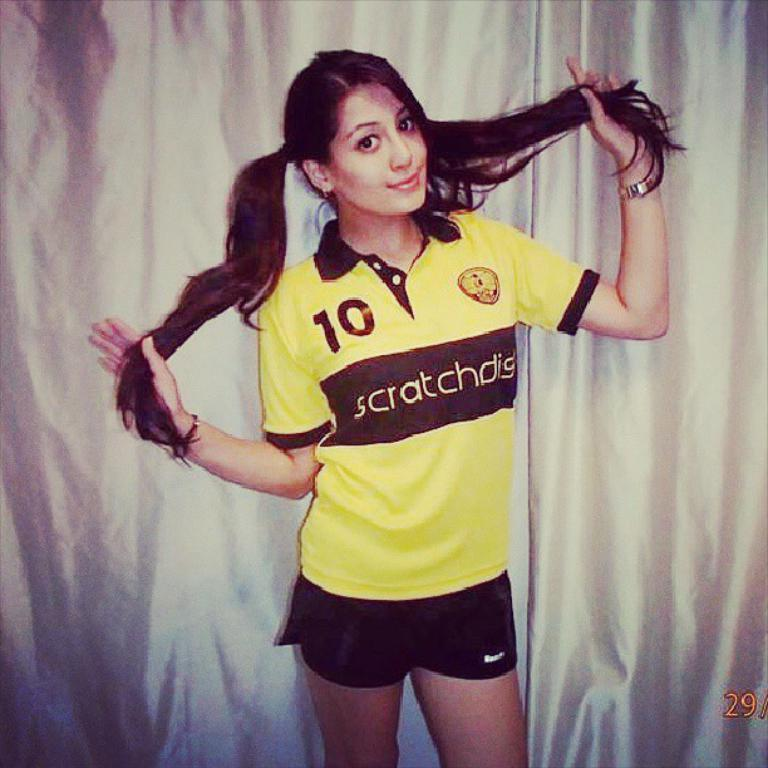<image>
Relay a brief, clear account of the picture shown. A young woman wears a yellow shirt with the number 10 on it over the word "sratchdis". 